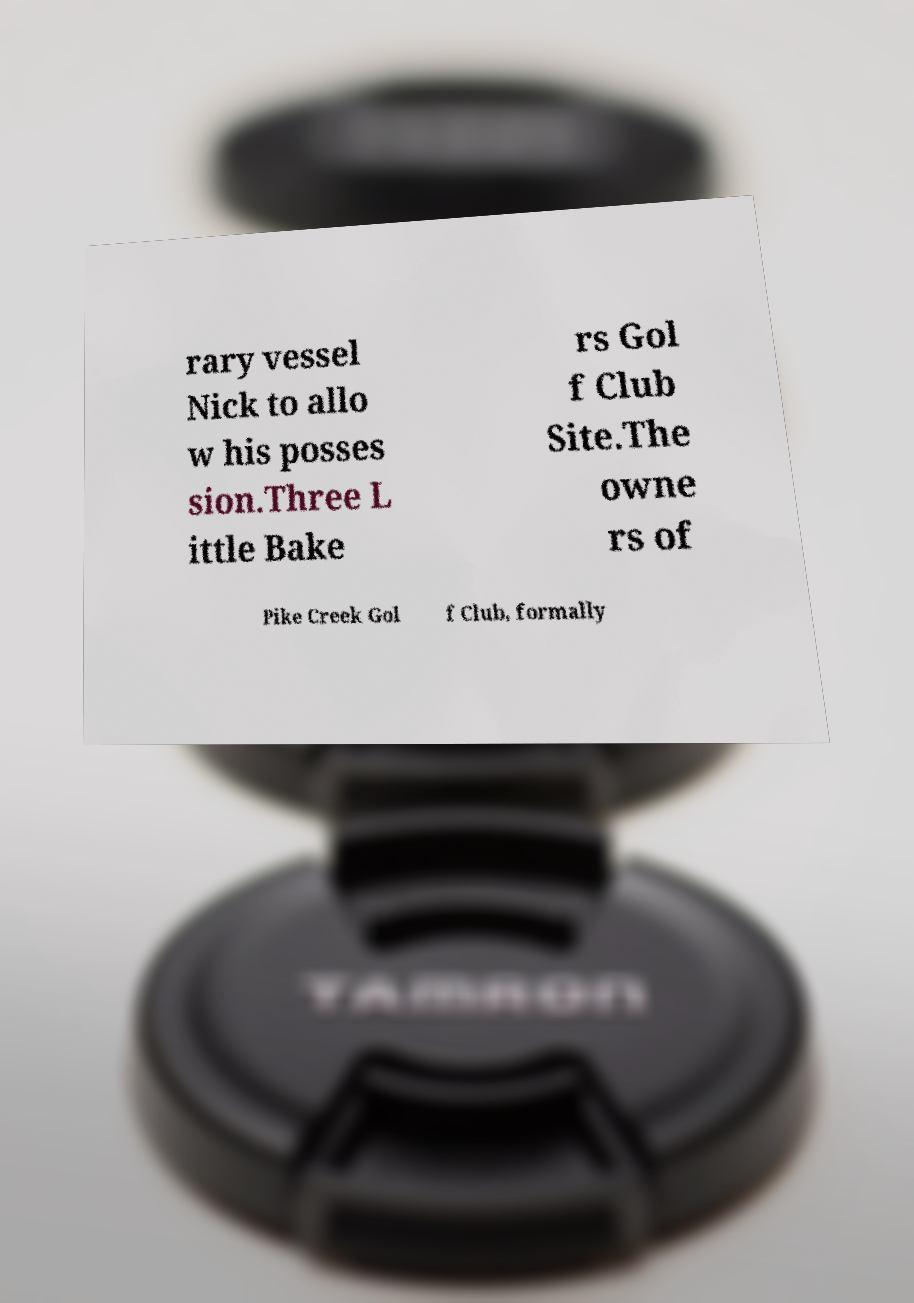For documentation purposes, I need the text within this image transcribed. Could you provide that? rary vessel Nick to allo w his posses sion.Three L ittle Bake rs Gol f Club Site.The owne rs of Pike Creek Gol f Club, formally 